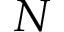<formula> <loc_0><loc_0><loc_500><loc_500>N</formula> 